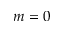<formula> <loc_0><loc_0><loc_500><loc_500>m = 0</formula> 